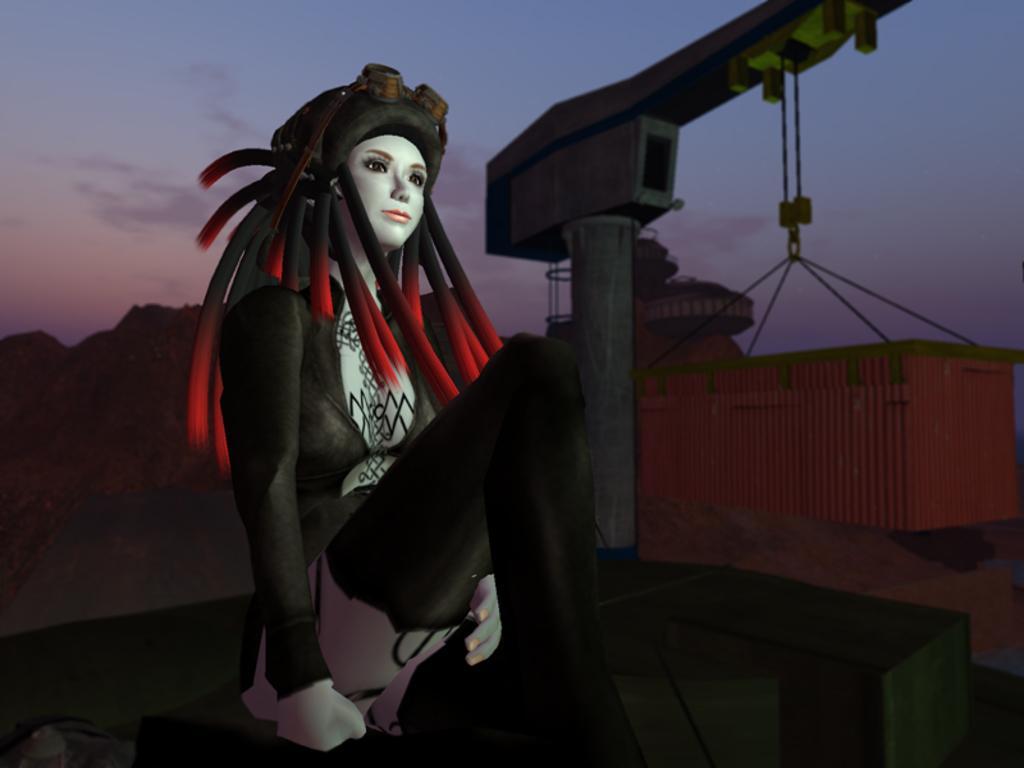Could you give a brief overview of what you see in this image? This image looks like it is animated. In the front, there is a woman sitting on a box. In the background, we can see a crane lifting a cabin. At the top, there are clouds in the sky. 